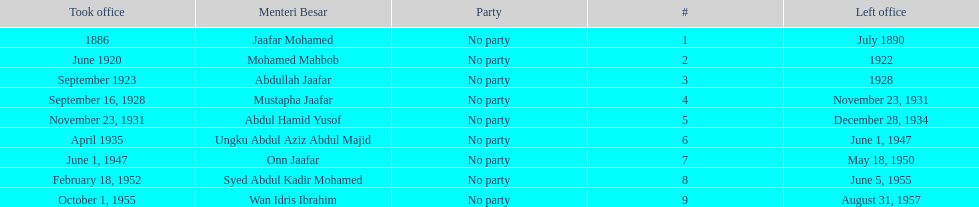Who served in the office immediately preceding abdullah jaafar? Mohamed Mahbob. 